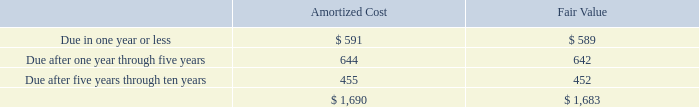The following table presents the contractual maturities of our debt investments as of April 26, 2019 (in millions):
Actual maturities may differ from the contractual maturities because borrowers may have the right to call or prepay certain obligations.
What type of cost and value information does the table provide about the contractual maturities of our debt investments as of April 26, 2019? Amortized cost, fair value. What was the amortized cost Due after one year through five years?
Answer scale should be: million. 644. What was the total fair value debt?
Answer scale should be: million. 1,683. What was the amortized cost that was due in one year or less as a ratio of the fair value for the same period?
Answer scale should be: percent. 591/589
Answer: 1. What was the difference between the amortized cost and fair value that was due after five years through ten years?
Answer scale should be: million. 455-452
Answer: 3. What was the difference in the total amortized cost and fair value?
Answer scale should be: million. 1,690-1,683
Answer: 7. 